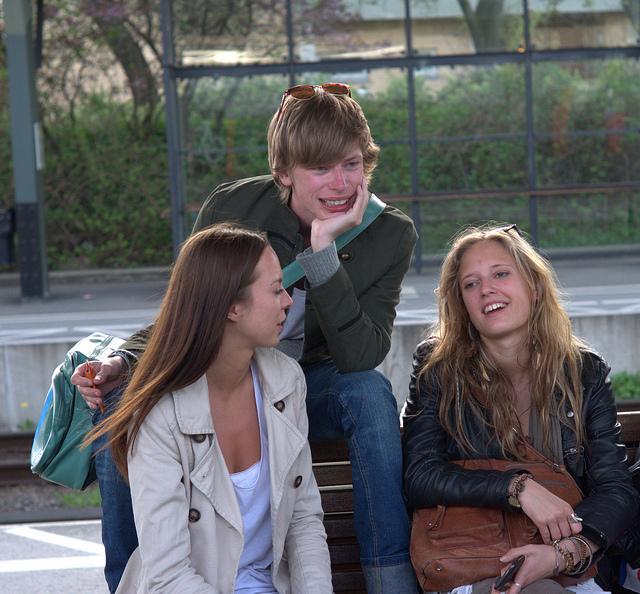Is the woman wearing glasses?
Quick response, please. No. How many have sunglasses?
Be succinct. 2. Are they all female?
Concise answer only. No. What color is the man's jacket?
Write a very short answer. Green. How many bags are there?
Write a very short answer. 2. 